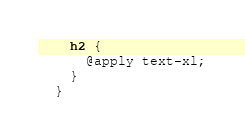Convert code to text. <code><loc_0><loc_0><loc_500><loc_500><_CSS_>    h2 {
      @apply text-xl;
    }
  }</code> 